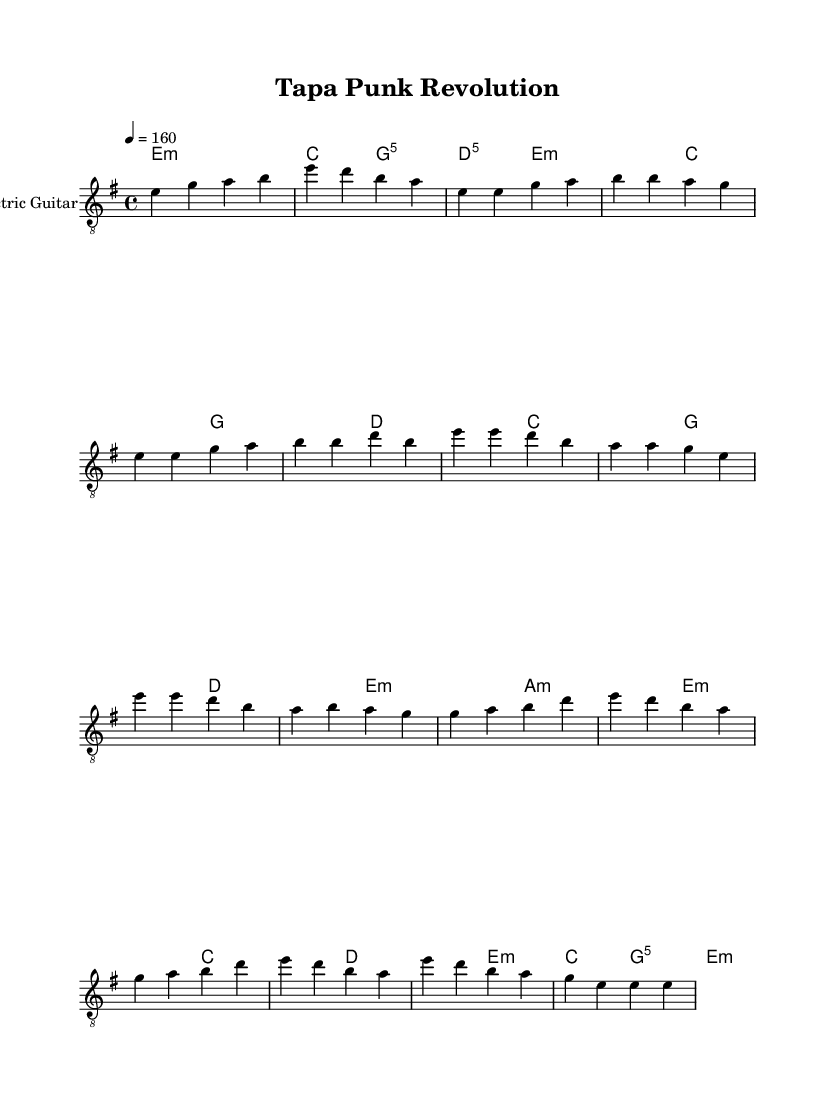What is the key signature of this music? The key signature is indicated by the number of sharps or flats at the beginning of the staff. Here, it shows one sharp near the clef, indicating E minor as the key signature.
Answer: E minor What is the time signature of this piece? The time signature is found at the beginning of the score, represented by two numbers stacked vertically. In this case, it shows 4/4, meaning there are four beats in each measure, and the quarter note gets one beat.
Answer: 4/4 What is the tempo marking of this music? The tempo marking reveals how fast the piece should be played. It is found in beats per minute. Here, it states "4 = 160," which means there are 160 beats for every minute, suggesting a fast and energetic pace suitable for punk music.
Answer: 160 How many sections are there in the music? The music is structured into different sections such as Intro, Verse, Chorus, Bridge, and Outro, each with distinct musical ideas. Counting these sections from the sheet music shows five entries.
Answer: Five sections What type of chord is primarily used in the intro? By examining the chord symbols written above the staff during the Intro, we note the chord is represented as "e:m," indicating it is an E minor chord, the fundamental chord for this opening.
Answer: E minor Why might the music be classified as punk? Punk music is characterized by its fast tempo, simple chord progressions, and often rebellious themes. This composition displays a fast tempo of 160, straightforward power chords, and the spirit of DIY and cultural celebration specific to Polynesian crafts, aligning with punk's ethos.
Answer: Fast tempo, simple chords, cultural celebration Which instrument is featured prominently in this score? The notation indicates there is a staff labeled "Electric Guitar," which highlights that the primary instrument featured in this sheet music is the electric guitar, a staple in punk rock music.
Answer: Electric Guitar 